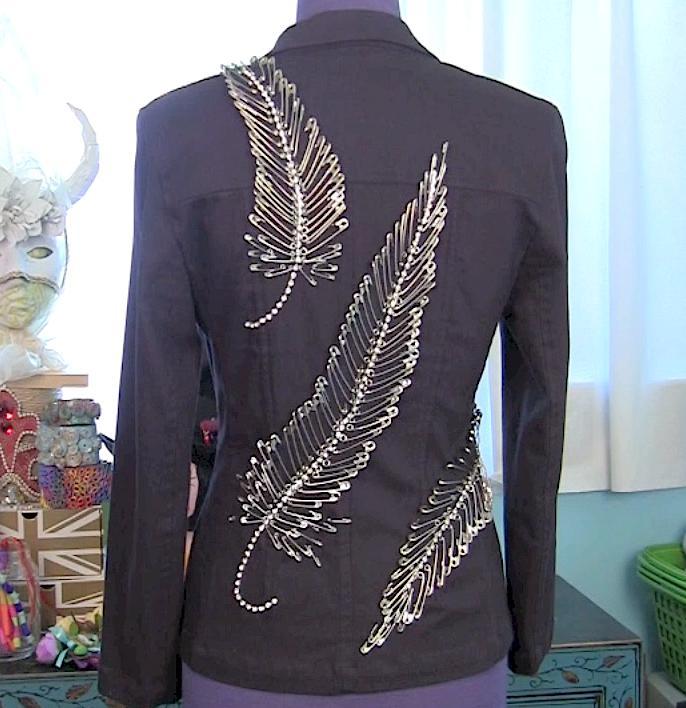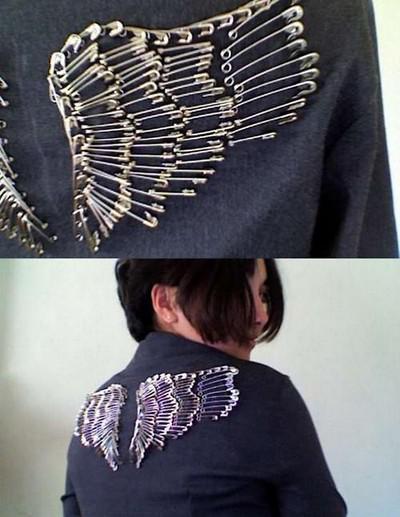The first image is the image on the left, the second image is the image on the right. For the images displayed, is the sentence "A woman models the back of a jacket decorated with pins in the shape of a complete bird." factually correct? Answer yes or no. No. 